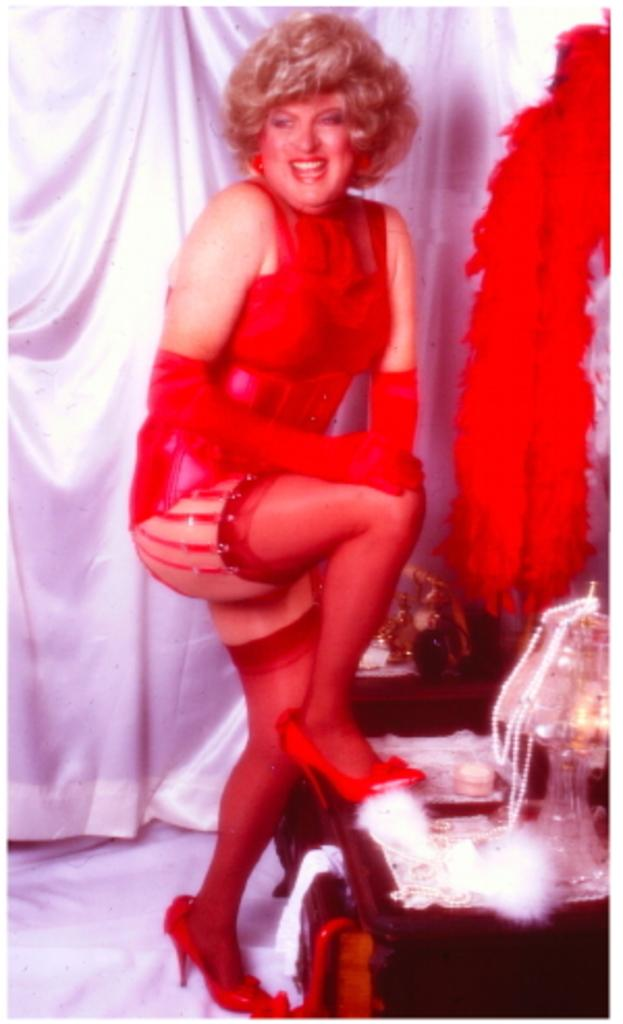Who is the main subject in the image? There is a lady in the center of the image. What can be seen in the background of the image? There is a curtain and streamers in the background of the image. Are there any other objects visible in the background? Yes, there are other objects on a stand in the background of the image. What type of beam is holding up the ceiling in the image? There is no beam visible in the image; it is not mentioned in the provided facts. 